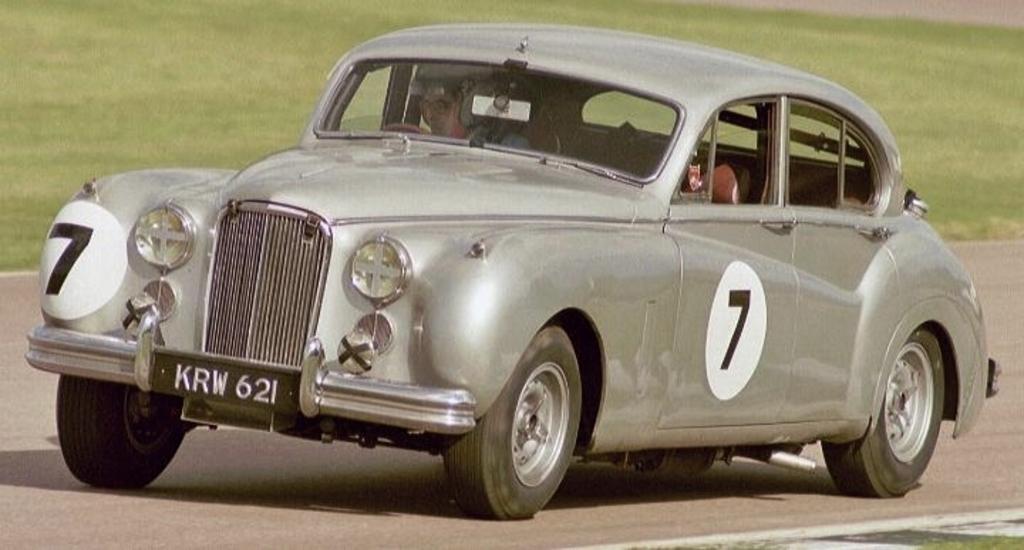Could you give a brief overview of what you see in this image? In this image, we can see person inside the car. In the background, image is blurred. 